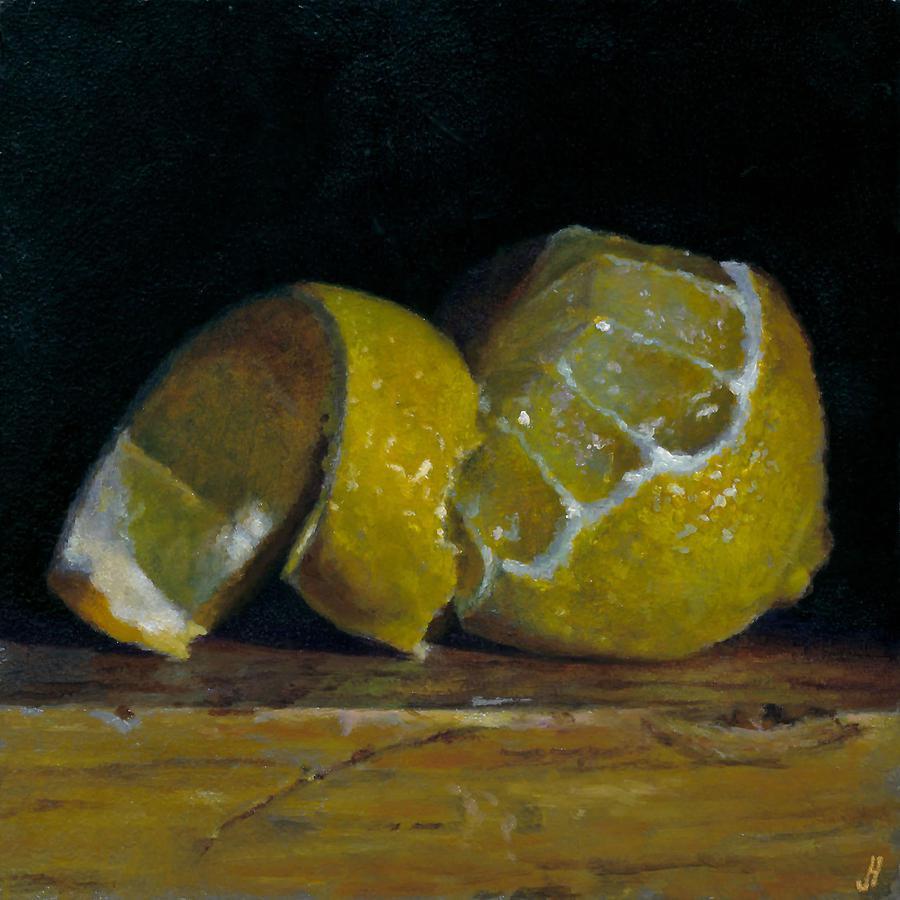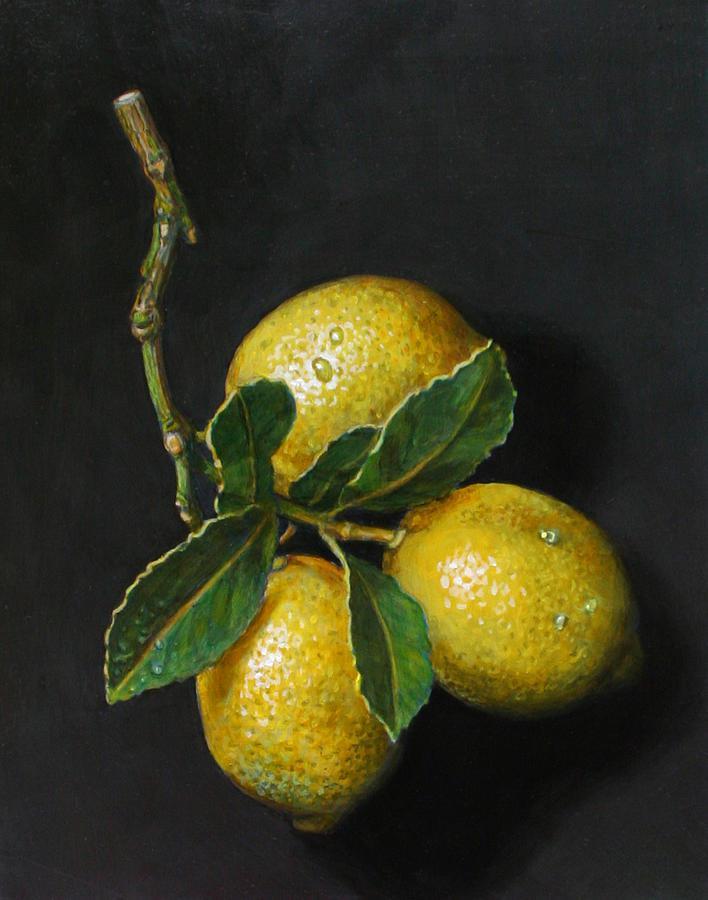The first image is the image on the left, the second image is the image on the right. Analyze the images presented: Is the assertion "There are three whole lemons lined up in a row in at least one of the images." valid? Answer yes or no. No. The first image is the image on the left, the second image is the image on the right. Evaluate the accuracy of this statement regarding the images: "Some lemons are in a bowl.". Is it true? Answer yes or no. No. 